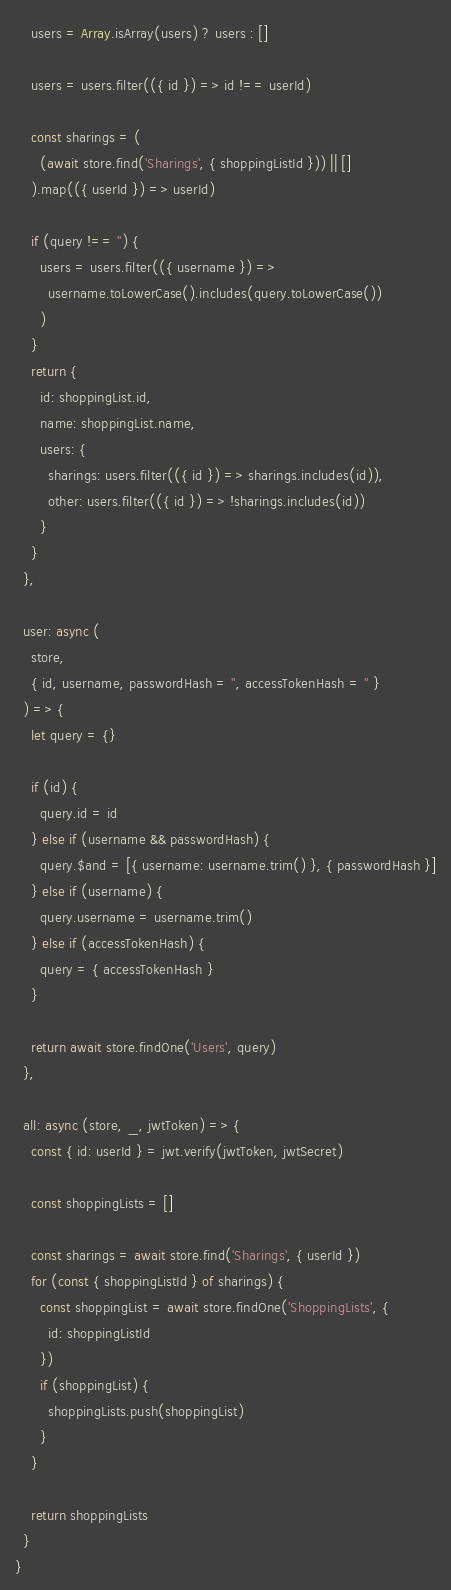<code> <loc_0><loc_0><loc_500><loc_500><_JavaScript_>    users = Array.isArray(users) ? users : []

    users = users.filter(({ id }) => id !== userId)

    const sharings = (
      (await store.find('Sharings', { shoppingListId })) || []
    ).map(({ userId }) => userId)

    if (query !== '') {
      users = users.filter(({ username }) =>
        username.toLowerCase().includes(query.toLowerCase())
      )
    }
    return {
      id: shoppingList.id,
      name: shoppingList.name,
      users: {
        sharings: users.filter(({ id }) => sharings.includes(id)),
        other: users.filter(({ id }) => !sharings.includes(id))
      }
    }
  },

  user: async (
    store,
    { id, username, passwordHash = '', accessTokenHash = '' }
  ) => {
    let query = {}

    if (id) {
      query.id = id
    } else if (username && passwordHash) {
      query.$and = [{ username: username.trim() }, { passwordHash }]
    } else if (username) {
      query.username = username.trim()
    } else if (accessTokenHash) {
      query = { accessTokenHash }
    }

    return await store.findOne('Users', query)
  },

  all: async (store, _, jwtToken) => {
    const { id: userId } = jwt.verify(jwtToken, jwtSecret)

    const shoppingLists = []

    const sharings = await store.find('Sharings', { userId })
    for (const { shoppingListId } of sharings) {
      const shoppingList = await store.findOne('ShoppingLists', {
        id: shoppingListId
      })
      if (shoppingList) {
        shoppingLists.push(shoppingList)
      }
    }

    return shoppingLists
  }
}
</code> 